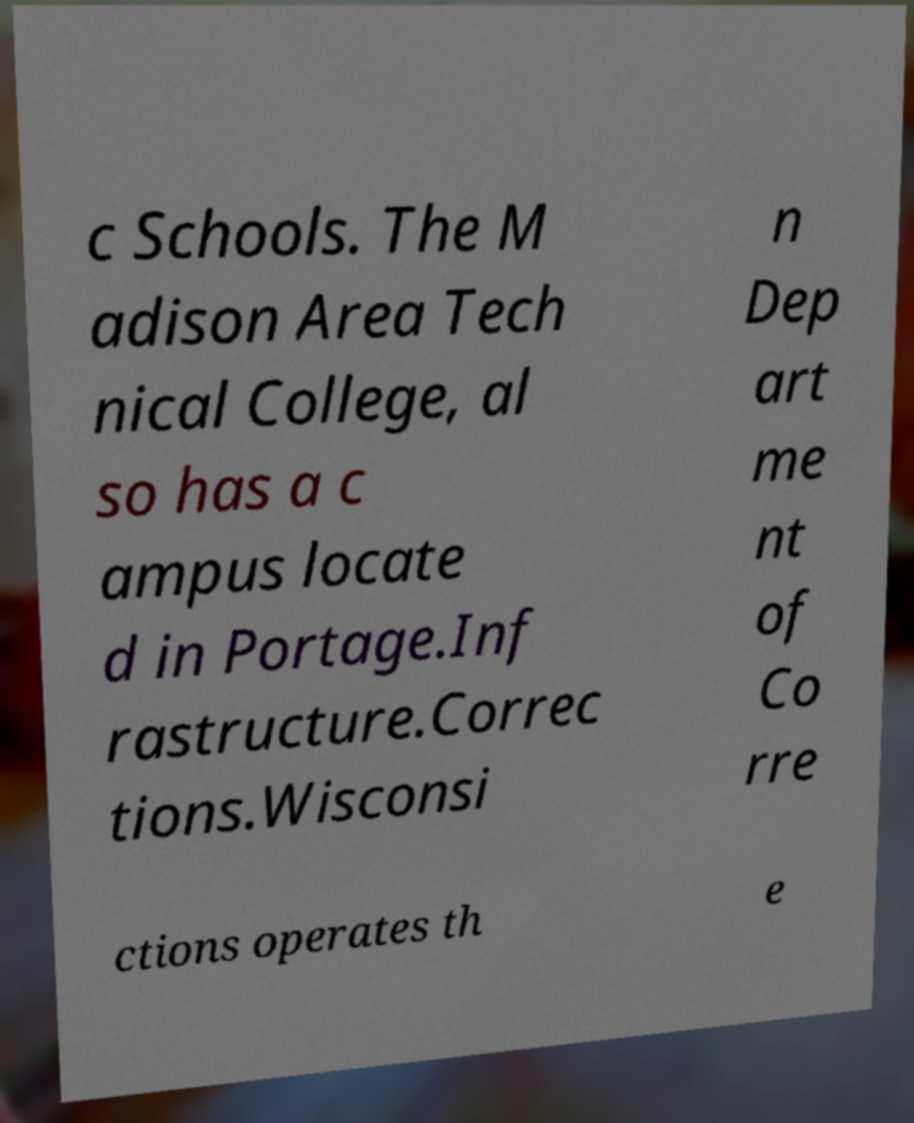What messages or text are displayed in this image? I need them in a readable, typed format. c Schools. The M adison Area Tech nical College, al so has a c ampus locate d in Portage.Inf rastructure.Correc tions.Wisconsi n Dep art me nt of Co rre ctions operates th e 